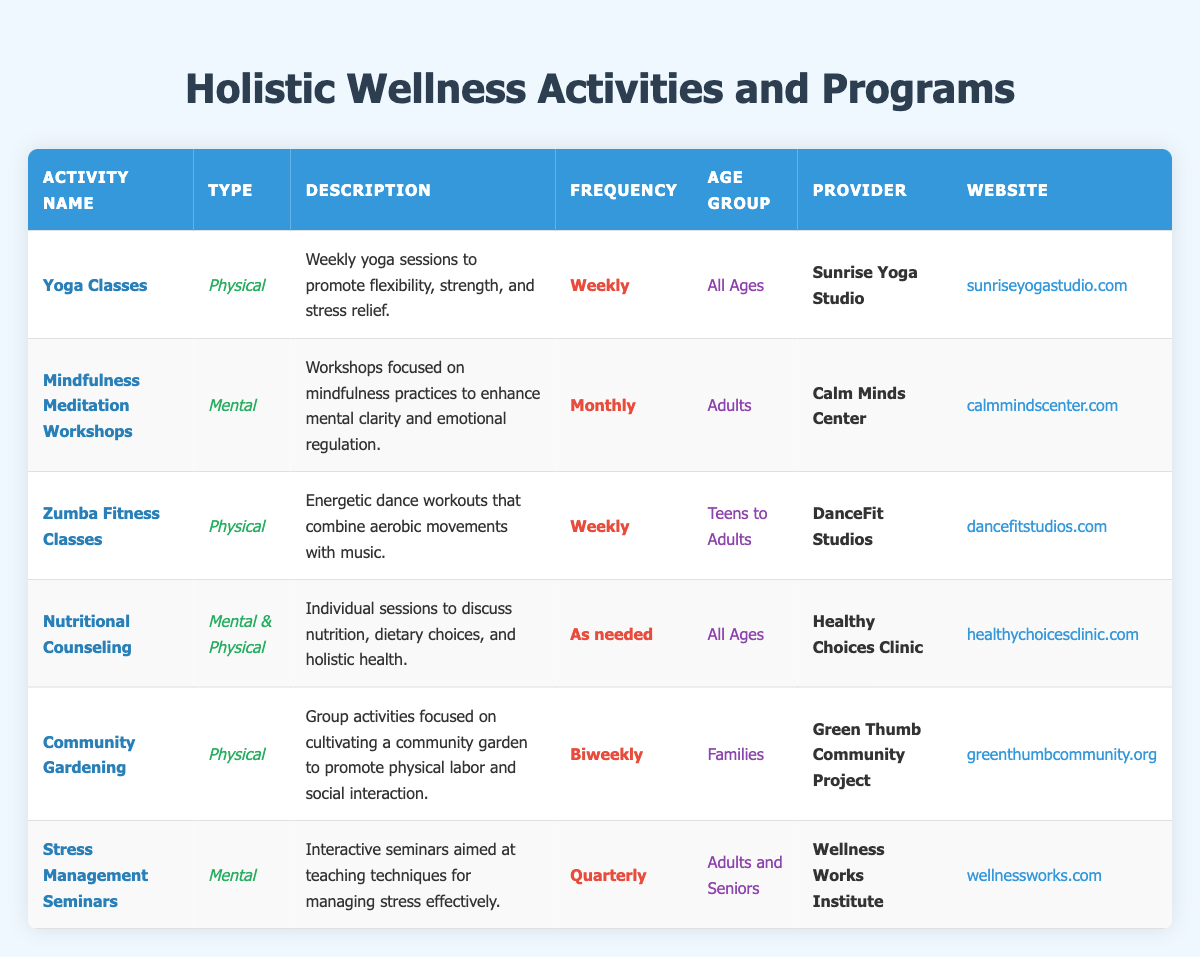What is the frequency of Yoga Classes? The table indicates that Yoga Classes are conducted weekly. I can find this in the "Frequency" column next to the "Yoga Classes" in the table.
Answer: Weekly Which age group is targeted by the Mindfulness Meditation Workshops? The "Age Group" column specifies that Mindfulness Meditation Workshops cater to adults. This information can be found directly in the table under the corresponding activity.
Answer: Adults How many activities are offered weekly? From the table, I can count the activities listed as having a frequency of "Weekly." There are 3 activities: Yoga Classes, Zumba Fitness Classes, and Nutritional Counseling. Therefore, the total is 3.
Answer: 3 Is Community Gardening targeted at all ages? According to the table, Community Gardening is targeted at families, which means it is not available for all ages. Therefore, the answer is no.
Answer: No Which provider offers Stress Management Seminars? The table lists "Wellness Works Institute" as the provider for Stress Management Seminars, which can be located directly in the "Provider" column corresponding to that activity.
Answer: Wellness Works Institute What types of wellness activities are available monthly? The table indicates that Mindfulness Meditation Workshops are the only activity offered monthly. Therefore, the answer is based on checking the "Frequency" column for activities that specify "Monthly."
Answer: Mindfulness Meditation Workshops Are there any activities that promote both mental and physical wellness? The table shows that Nutritional Counseling is labeled as both mental and physical wellness. This means the answer is yes.
Answer: Yes How many different age groups are catered to in the activities listed? By reviewing the "Age Group" column, I can identify variations: All Ages, Adults, Teens to Adults, and Families. This indicates there are 4 distinct categories of age groups in the activities.
Answer: 4 